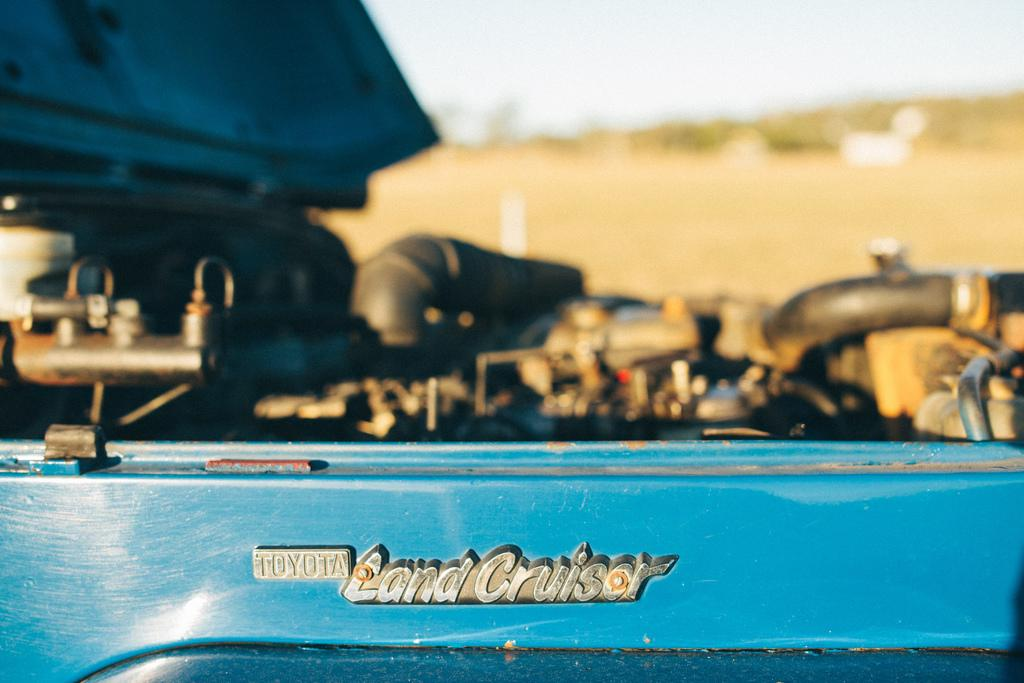What type of vehicle is in the image? There is a blue vehicle in the image, specifically a 'land cruiser'. How is the vehicle shown in the image? The vehicle is shown from the side. What can be observed about the background of the image? The background of the image is blurred. What type of wood is used to make the loaf in the image? There is no wood or loaf present in the image; it features a blue 'land cruiser' vehicle. 